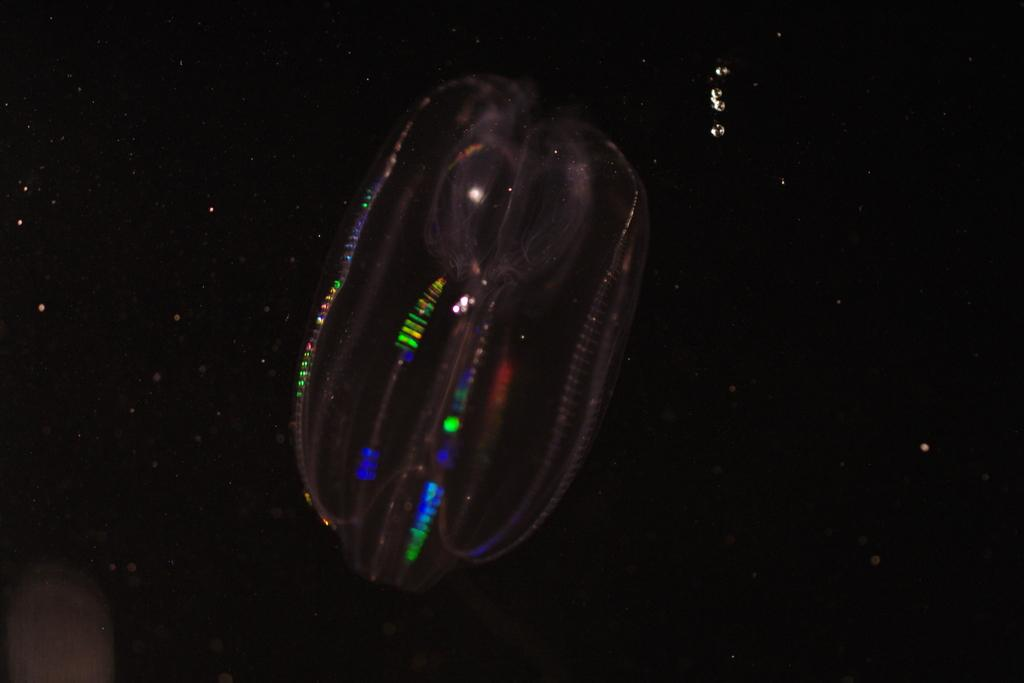What is the main subject of the image? There is an object in the center of the image. Can you describe the background of the image? The background of the image is dark. How many clams are sitting on the soda can in the image? There is no soda can or clams present in the image. 